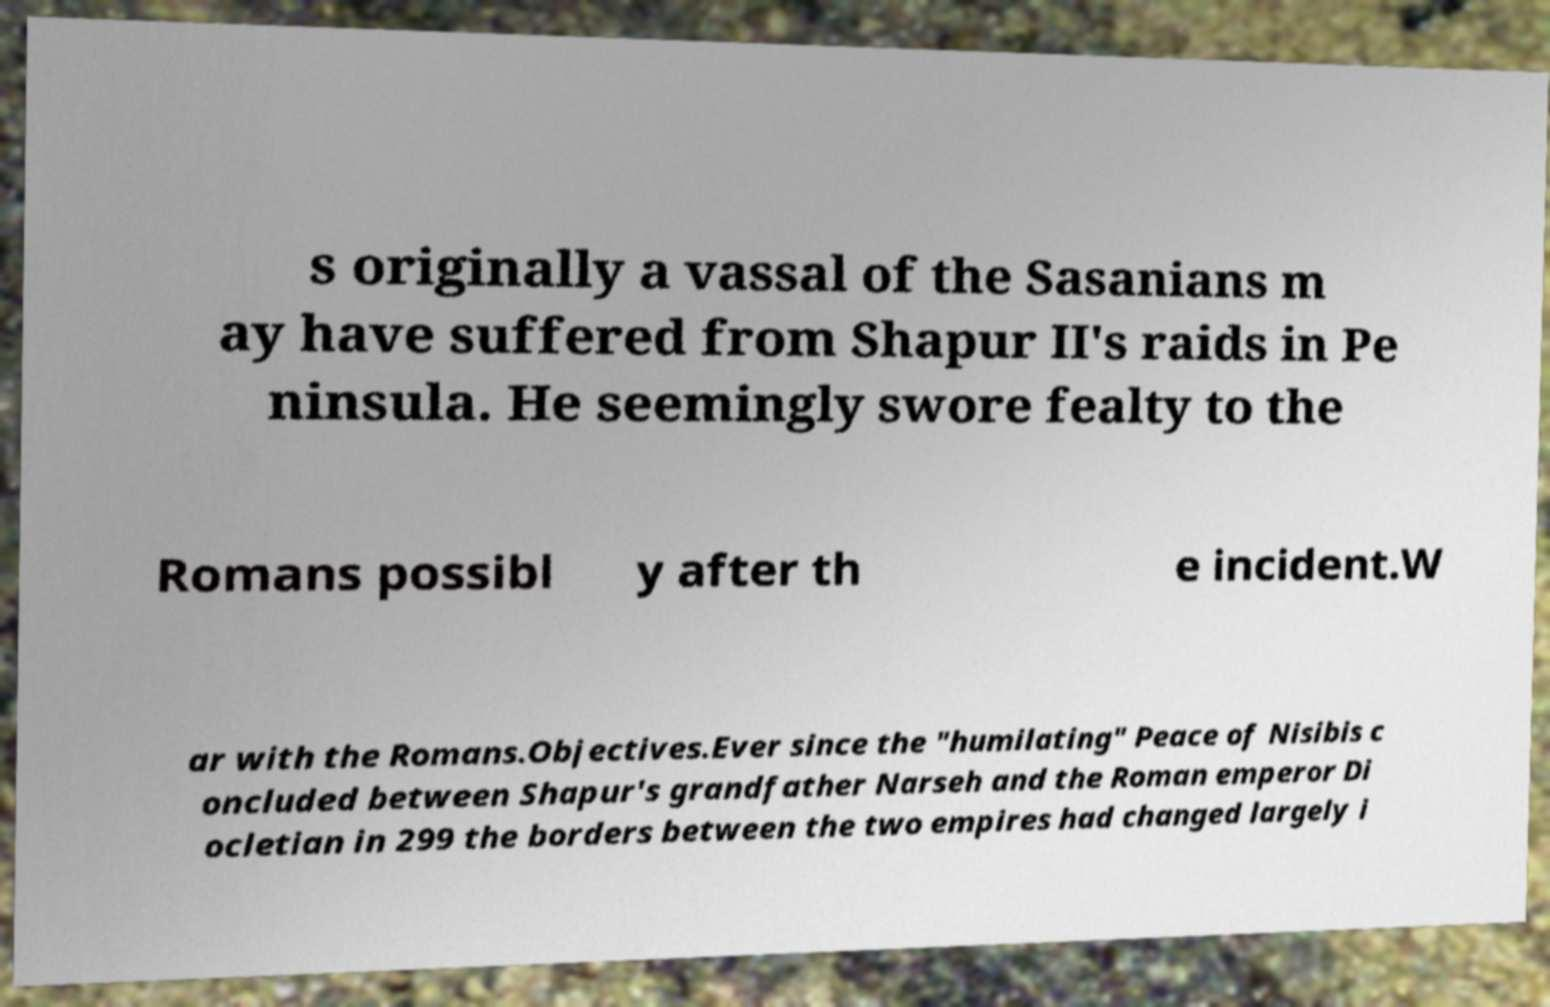Can you read and provide the text displayed in the image?This photo seems to have some interesting text. Can you extract and type it out for me? s originally a vassal of the Sasanians m ay have suffered from Shapur II's raids in Pe ninsula. He seemingly swore fealty to the Romans possibl y after th e incident.W ar with the Romans.Objectives.Ever since the "humilating" Peace of Nisibis c oncluded between Shapur's grandfather Narseh and the Roman emperor Di ocletian in 299 the borders between the two empires had changed largely i 